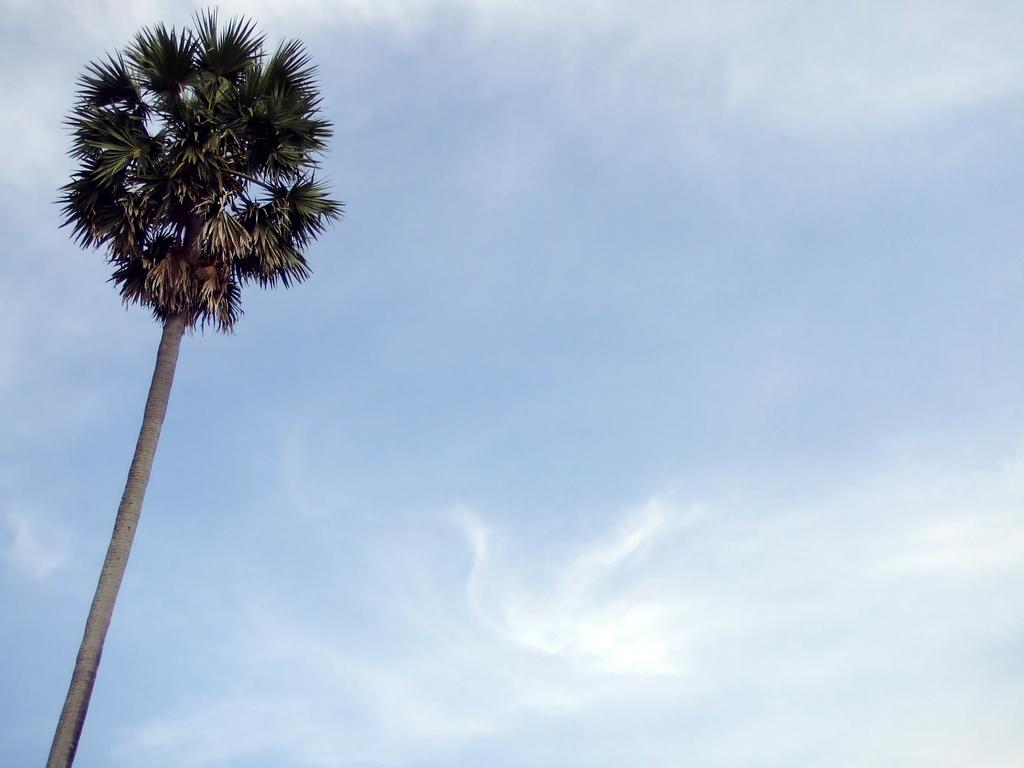What type of vegetation is on the left side of the image? There is a tall tree on the left side of the image. What can be seen in the background of the image? The sky is visible in the background of the image. What songs are being sung by the truck in the image? There is no truck present in the image, so no songs can be sung by a truck. 